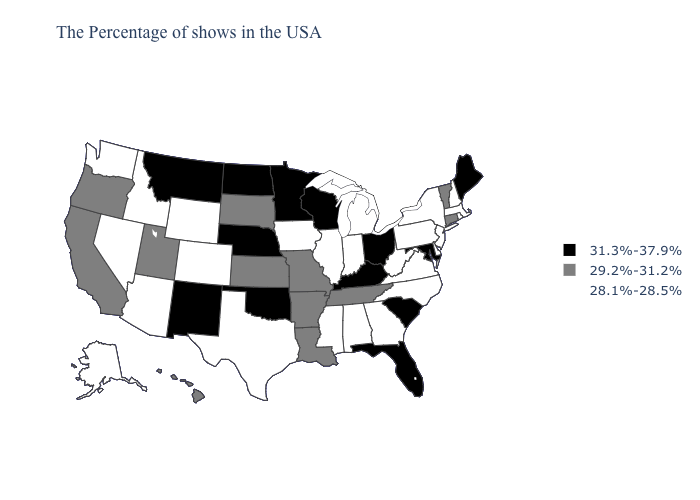What is the value of Kansas?
Quick response, please. 29.2%-31.2%. What is the value of Montana?
Quick response, please. 31.3%-37.9%. Name the states that have a value in the range 31.3%-37.9%?
Keep it brief. Maine, Maryland, South Carolina, Ohio, Florida, Kentucky, Wisconsin, Minnesota, Nebraska, Oklahoma, North Dakota, New Mexico, Montana. Does Louisiana have the same value as Georgia?
Give a very brief answer. No. Does Oregon have the lowest value in the West?
Write a very short answer. No. Does the first symbol in the legend represent the smallest category?
Quick response, please. No. What is the lowest value in states that border Georgia?
Write a very short answer. 28.1%-28.5%. Name the states that have a value in the range 31.3%-37.9%?
Concise answer only. Maine, Maryland, South Carolina, Ohio, Florida, Kentucky, Wisconsin, Minnesota, Nebraska, Oklahoma, North Dakota, New Mexico, Montana. What is the value of South Dakota?
Answer briefly. 29.2%-31.2%. Name the states that have a value in the range 29.2%-31.2%?
Short answer required. Vermont, Connecticut, Tennessee, Louisiana, Missouri, Arkansas, Kansas, South Dakota, Utah, California, Oregon, Hawaii. Which states have the highest value in the USA?
Answer briefly. Maine, Maryland, South Carolina, Ohio, Florida, Kentucky, Wisconsin, Minnesota, Nebraska, Oklahoma, North Dakota, New Mexico, Montana. What is the value of Rhode Island?
Be succinct. 28.1%-28.5%. Is the legend a continuous bar?
Keep it brief. No. What is the lowest value in states that border Montana?
Quick response, please. 28.1%-28.5%. Does Michigan have a lower value than Arizona?
Short answer required. No. 